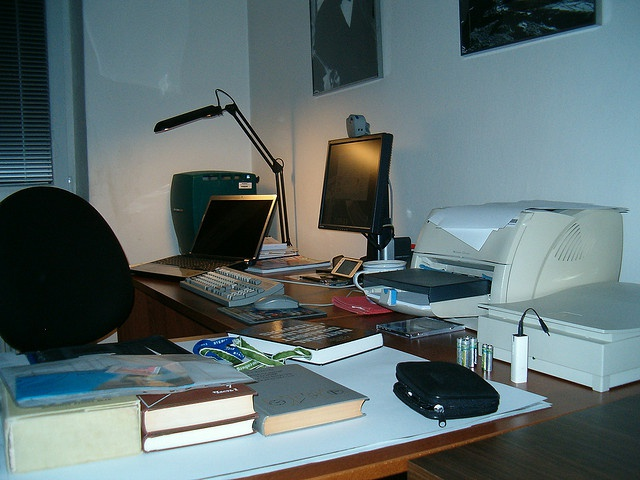Describe the objects in this image and their specific colors. I can see chair in black, maroon, and gray tones, book in black, beige, lightgray, and darkgray tones, laptop in black, gray, and maroon tones, book in black, gray, tan, and darkgray tones, and book in black, lightblue, and gray tones in this image. 